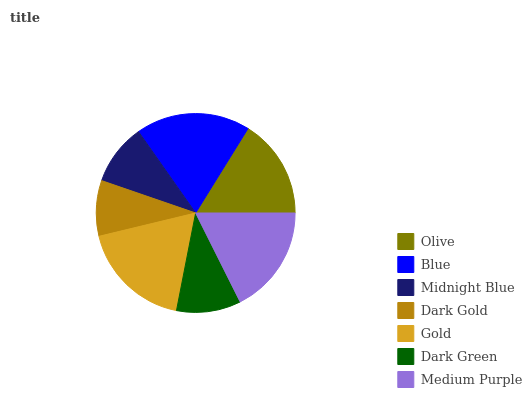Is Dark Gold the minimum?
Answer yes or no. Yes. Is Blue the maximum?
Answer yes or no. Yes. Is Midnight Blue the minimum?
Answer yes or no. No. Is Midnight Blue the maximum?
Answer yes or no. No. Is Blue greater than Midnight Blue?
Answer yes or no. Yes. Is Midnight Blue less than Blue?
Answer yes or no. Yes. Is Midnight Blue greater than Blue?
Answer yes or no. No. Is Blue less than Midnight Blue?
Answer yes or no. No. Is Olive the high median?
Answer yes or no. Yes. Is Olive the low median?
Answer yes or no. Yes. Is Dark Green the high median?
Answer yes or no. No. Is Dark Gold the low median?
Answer yes or no. No. 